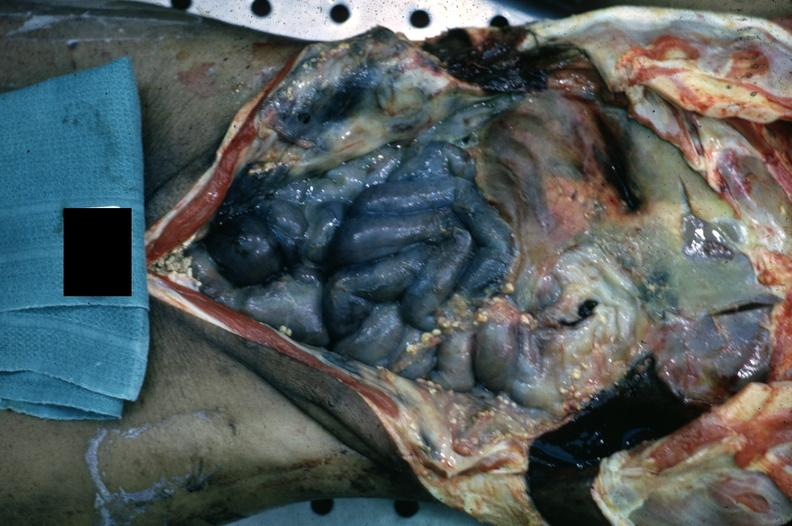s metastatic carcinoma prostate present?
Answer the question using a single word or phrase. No 